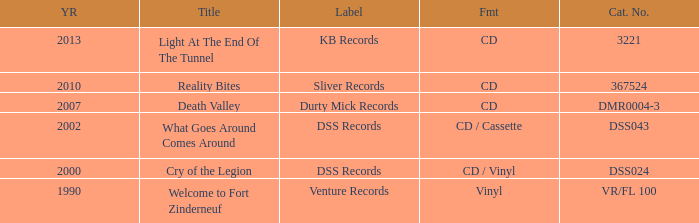What is the total year of release of the title what goes around comes around? 1.0. Could you parse the entire table as a dict? {'header': ['YR', 'Title', 'Label', 'Fmt', 'Cat. No.'], 'rows': [['2013', 'Light At The End Of The Tunnel', 'KB Records', 'CD', '3221'], ['2010', 'Reality Bites', 'Sliver Records', 'CD', '367524'], ['2007', 'Death Valley', 'Durty Mick Records', 'CD', 'DMR0004-3'], ['2002', 'What Goes Around Comes Around', 'DSS Records', 'CD / Cassette', 'DSS043'], ['2000', 'Cry of the Legion', 'DSS Records', 'CD / Vinyl', 'DSS024'], ['1990', 'Welcome to Fort Zinderneuf', 'Venture Records', 'Vinyl', 'VR/FL 100']]} 